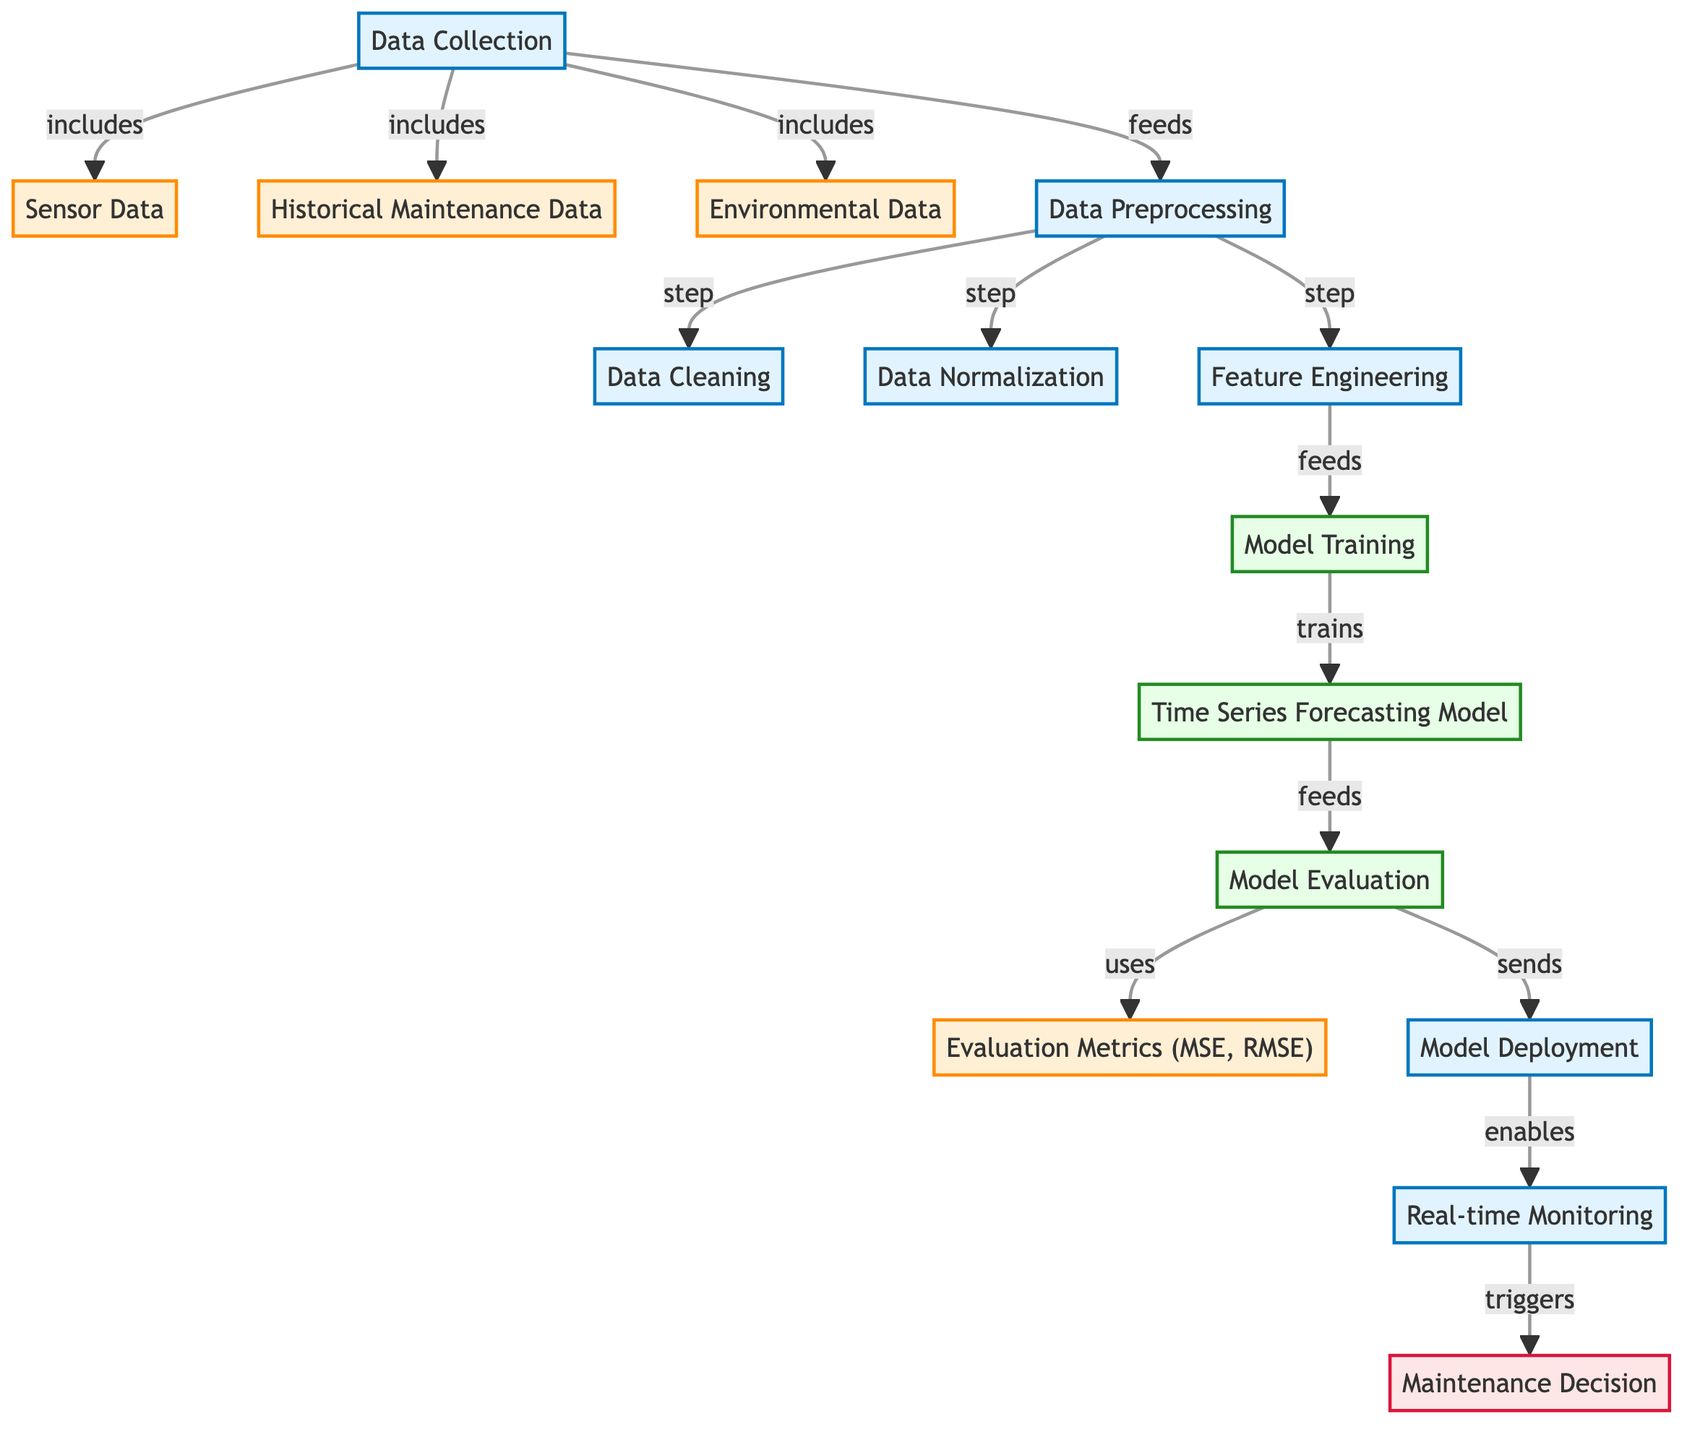What's the first step in the process? The diagram starts with "Data Collection" as the initial step in the predictive maintenance process.
Answer: Data Collection How many types of data are collected? Three types of data are collected: Sensor Data, Historical Maintenance Data, and Environmental Data.
Answer: Three What is the last process indicated in the diagram? The last process indicated is "Maintenance Decision," which receives input from "Real-time Monitoring."
Answer: Maintenance Decision Which process comes after Feature Engineering? After Feature Engineering, the next step in the process is "Model Training."
Answer: Model Training What is used to evaluate the model? The model evaluation uses evaluation metrics, specifically MSE and RMSE.
Answer: Evaluation Metrics (MSE, RMSE) What feeds into the Model Training? Feature Engineering feeds into Model Training, as indicated by the directional arrow.
Answer: Feature Engineering What triggers the Maintenance Decision? The "Real-time Monitoring" process triggers the Maintenance Decision in the flow.
Answer: Real-time Monitoring What type of model is being trained? The diagram specifies that a "Time Series Forecasting Model" is being trained through the model training process.
Answer: Time Series Forecasting Model How many preprocessing steps are mentioned in the diagram? There are three preprocessing steps mentioned: Data Cleaning, Data Normalization, and Feature Engineering.
Answer: Three 